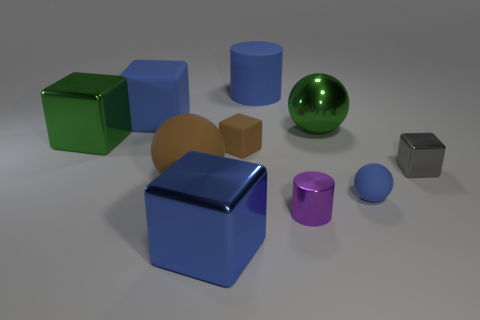Subtract all gray blocks. How many blocks are left? 4 Subtract all tiny shiny cubes. How many cubes are left? 4 Subtract all cyan blocks. Subtract all green cylinders. How many blocks are left? 5 Subtract all balls. How many objects are left? 7 Subtract all big blue cylinders. Subtract all purple metal cylinders. How many objects are left? 8 Add 2 gray cubes. How many gray cubes are left? 3 Add 9 big matte cylinders. How many big matte cylinders exist? 10 Subtract 1 brown blocks. How many objects are left? 9 